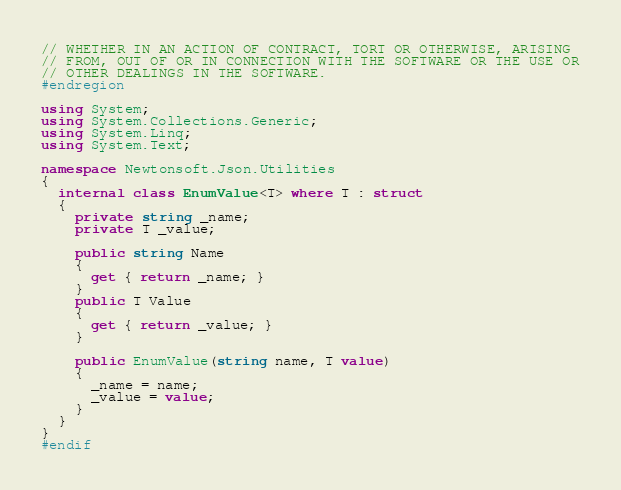<code> <loc_0><loc_0><loc_500><loc_500><_C#_>// WHETHER IN AN ACTION OF CONTRACT, TORT OR OTHERWISE, ARISING
// FROM, OUT OF OR IN CONNECTION WITH THE SOFTWARE OR THE USE OR
// OTHER DEALINGS IN THE SOFTWARE.
#endregion

using System;
using System.Collections.Generic;
using System.Linq;
using System.Text;

namespace Newtonsoft.Json.Utilities
{
  internal class EnumValue<T> where T : struct
  {
    private string _name;
    private T _value;

    public string Name
    {
      get { return _name; }
    }
    public T Value
    {
      get { return _value; }
    }

    public EnumValue(string name, T value)
    {
      _name = name;
      _value = value;
    }
  }
}
#endif</code> 